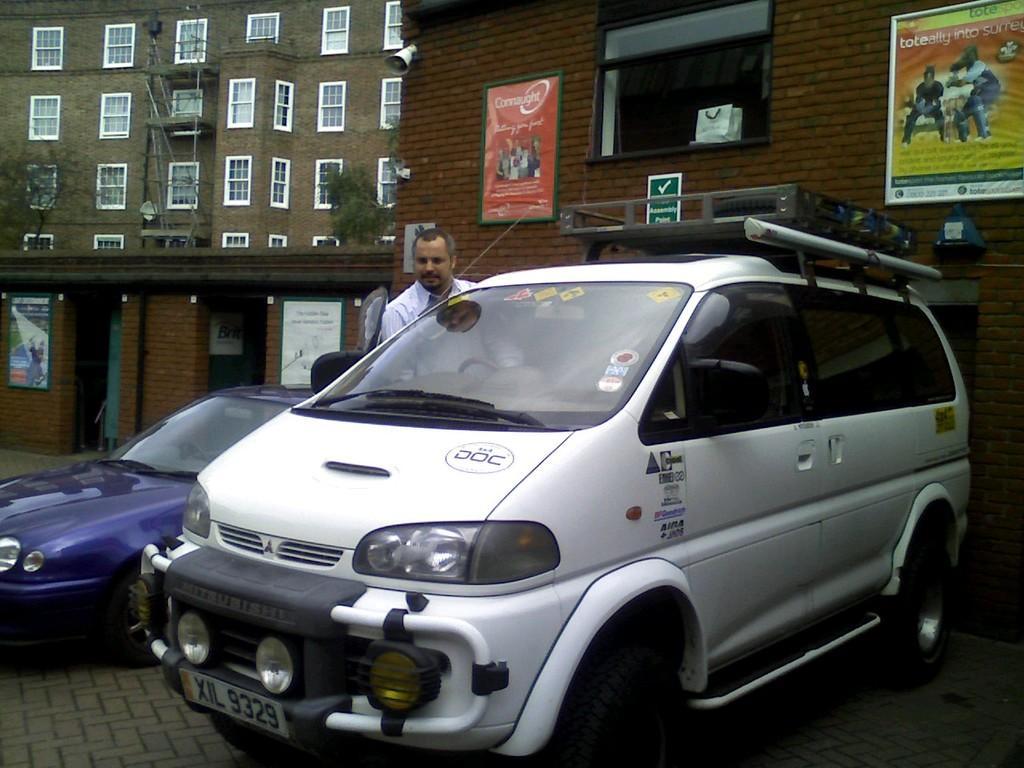In one or two sentences, can you explain what this image depicts? In this image we can see two cars which are parked are of different colors and a person wearing white color dress boarding white color car and at the background of the image there are some buildings, trees and some paintings attached to the building. 